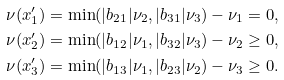Convert formula to latex. <formula><loc_0><loc_0><loc_500><loc_500>\nu ( x ^ { \prime } _ { 1 } ) & = \min ( | b _ { 2 1 } | \nu _ { 2 } , | b _ { 3 1 } | \nu _ { 3 } ) - \nu _ { 1 } = 0 , \\ \nu ( x ^ { \prime } _ { 2 } ) & = \min ( | b _ { 1 2 } | \nu _ { 1 } , | b _ { 3 2 } | \nu _ { 3 } ) - \nu _ { 2 } \geq 0 , \\ \nu ( x ^ { \prime } _ { 3 } ) & = \min ( | b _ { 1 3 } | \nu _ { 1 } , | b _ { 2 3 } | \nu _ { 2 } ) - \nu _ { 3 } \geq 0 .</formula> 